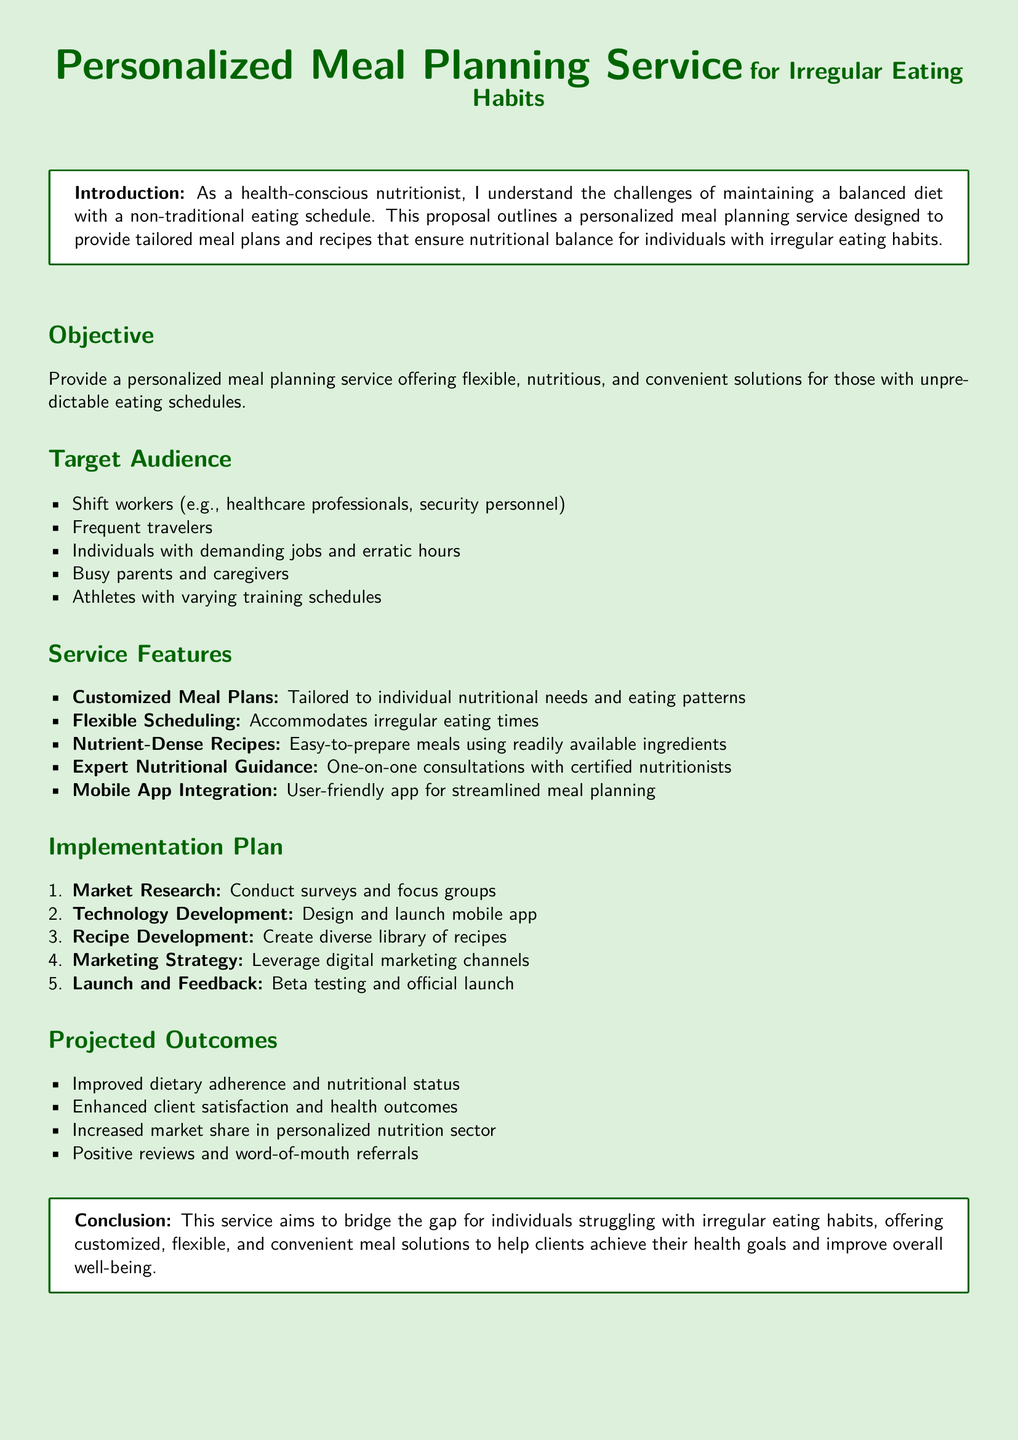What is the title of the proposal? The title of the proposal is clearly stated at the beginning of the document, which is "Personalized Meal Planning Service for Irregular Eating Habits."
Answer: Personalized Meal Planning Service for Irregular Eating Habits What is the primary objective of the service? The primary objective is mentioned directly under the Objective section of the proposal.
Answer: Provide a personalized meal planning service offering flexible, nutritious, and convenient solutions for those with unpredictable eating schedules Who is the target audience for this service? The document lists the target audience in the Target Audience section, detailing various groups that will benefit from the service.
Answer: Shift workers, Frequent travelers, Individuals with demanding jobs and erratic hours, Busy parents and caregivers, Athletes with varying training schedules What feature ensures the meal plans are tailored? The feature that ensures the meal plans are tailored is specified in the Service Features section.
Answer: Customized Meal Plans How many steps are in the implementation plan? The number of steps can be counted in the Implementation Plan section, which outlines the process sequentially.
Answer: Five What is one expected outcome of the service? The document lists several expected outcomes in the Projected Outcomes section; one can be selected for the response.
Answer: Improved dietary adherence and nutritional status What is the primary goal stated in the conclusion? The conclusion summarizes the aim of the service, encapsulating the main goal or mission of the proposal.
Answer: Offer customized, flexible, and convenient meal solutions How will the service be marketed? The document outlines how the service will be marketed in the Implementation Plan section.
Answer: Leverage digital marketing channels 